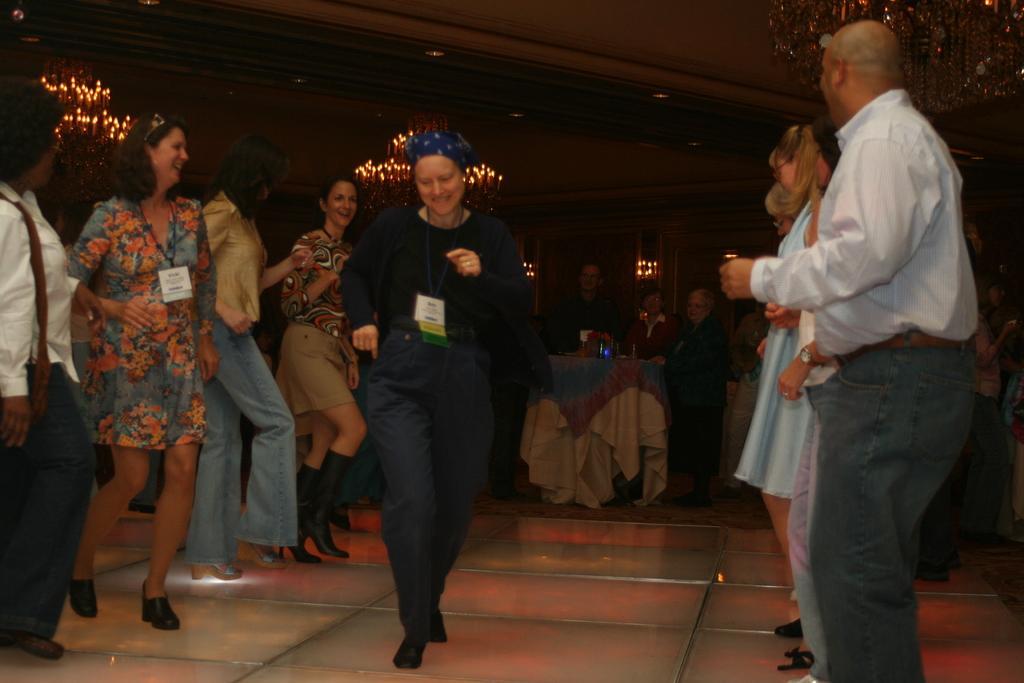Could you give a brief overview of what you see in this image? This is an image clicked in the dark. In the middle of the image there is a woman dancing on the floor. On the right and left side of the image I can see few people are dancing by looking at this woman. In the background there is a table with is covered with a cloth and I can see few objects on it and also there are few people standing. The background is dark. 